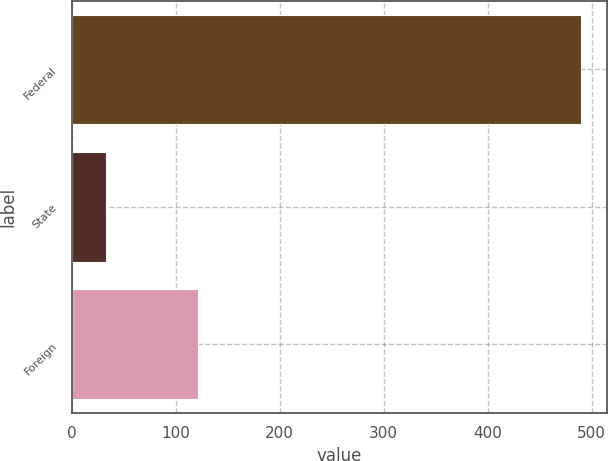<chart> <loc_0><loc_0><loc_500><loc_500><bar_chart><fcel>Federal<fcel>State<fcel>Foreign<nl><fcel>490<fcel>33<fcel>121<nl></chart> 